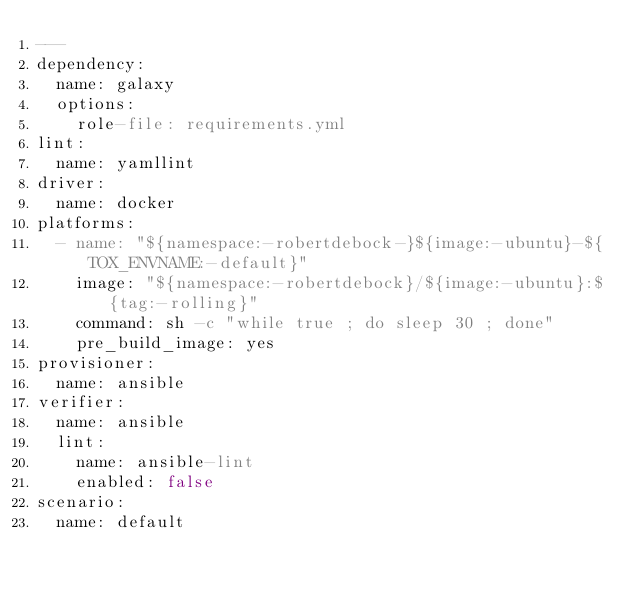Convert code to text. <code><loc_0><loc_0><loc_500><loc_500><_YAML_>---
dependency:
  name: galaxy
  options:
    role-file: requirements.yml
lint:
  name: yamllint
driver:
  name: docker
platforms:
  - name: "${namespace:-robertdebock-}${image:-ubuntu}-${TOX_ENVNAME:-default}"
    image: "${namespace:-robertdebock}/${image:-ubuntu}:${tag:-rolling}"
    command: sh -c "while true ; do sleep 30 ; done"
    pre_build_image: yes
provisioner:
  name: ansible
verifier:
  name: ansible
  lint:
    name: ansible-lint
    enabled: false
scenario:
  name: default
</code> 